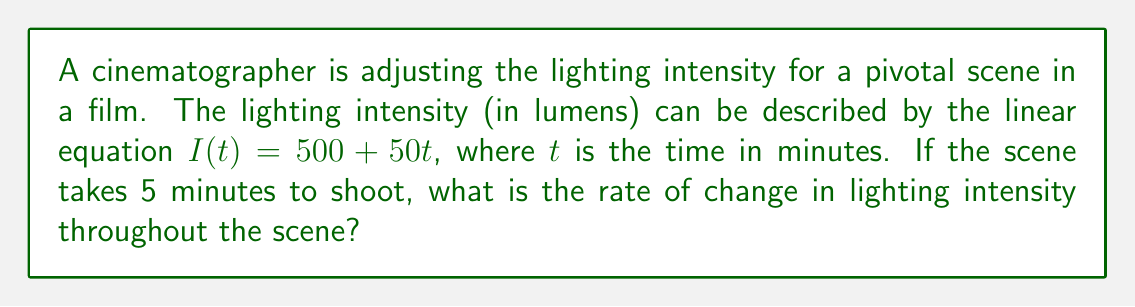Solve this math problem. To determine the rate of change in lighting intensity, we need to analyze the given linear equation:

1. The equation is in the form $I(t) = mt + b$, where:
   $I(t)$ is the lighting intensity in lumens
   $t$ is the time in minutes
   $m$ is the slope (rate of change)
   $b$ is the y-intercept (initial intensity)

2. In this case, we have $I(t) = 50t + 500$

3. The slope $m$ represents the rate of change. In this equation, $m = 50$

4. This means that for each minute (unit of $t$), the lighting intensity increases by 50 lumens

5. The rate of change is constant throughout the linear function, so it doesn't matter that the scene takes 5 minutes to shoot. The rate remains the same for the entire duration

Therefore, the rate of change in lighting intensity is 50 lumens per minute.
Answer: 50 lumens/minute 